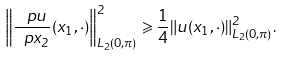<formula> <loc_0><loc_0><loc_500><loc_500>\left \| \frac { \ p u } { \ p x _ { 2 } } ( x _ { 1 } , \cdot ) \right \| _ { L _ { 2 } ( 0 , \pi ) } ^ { 2 } \geqslant \frac { 1 } { 4 } \| u ( x _ { 1 } , \cdot ) \| _ { L _ { 2 } ( 0 , \pi ) } ^ { 2 } .</formula> 